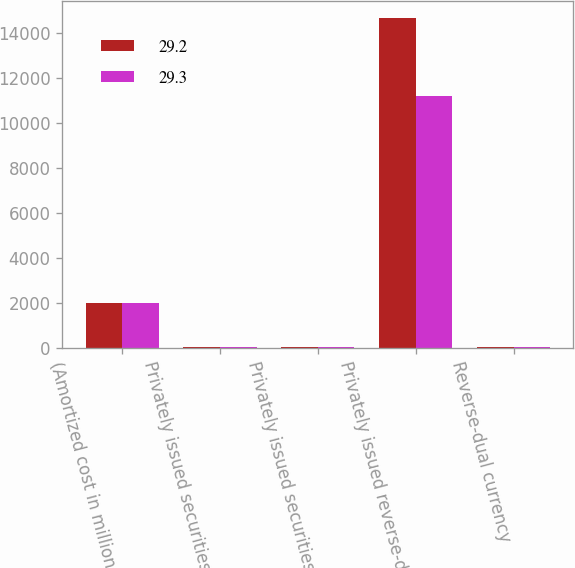Convert chart to OTSL. <chart><loc_0><loc_0><loc_500><loc_500><stacked_bar_chart><ecel><fcel>(Amortized cost in millions)<fcel>Privately issued securities as<fcel>Privately issued securities<fcel>Privately issued reverse-dual<fcel>Reverse-dual currency<nl><fcel>29.2<fcel>2008<fcel>72<fcel>68.3<fcel>14678<fcel>29.3<nl><fcel>29.3<fcel>2007<fcel>70.3<fcel>66<fcel>11185<fcel>29.2<nl></chart> 